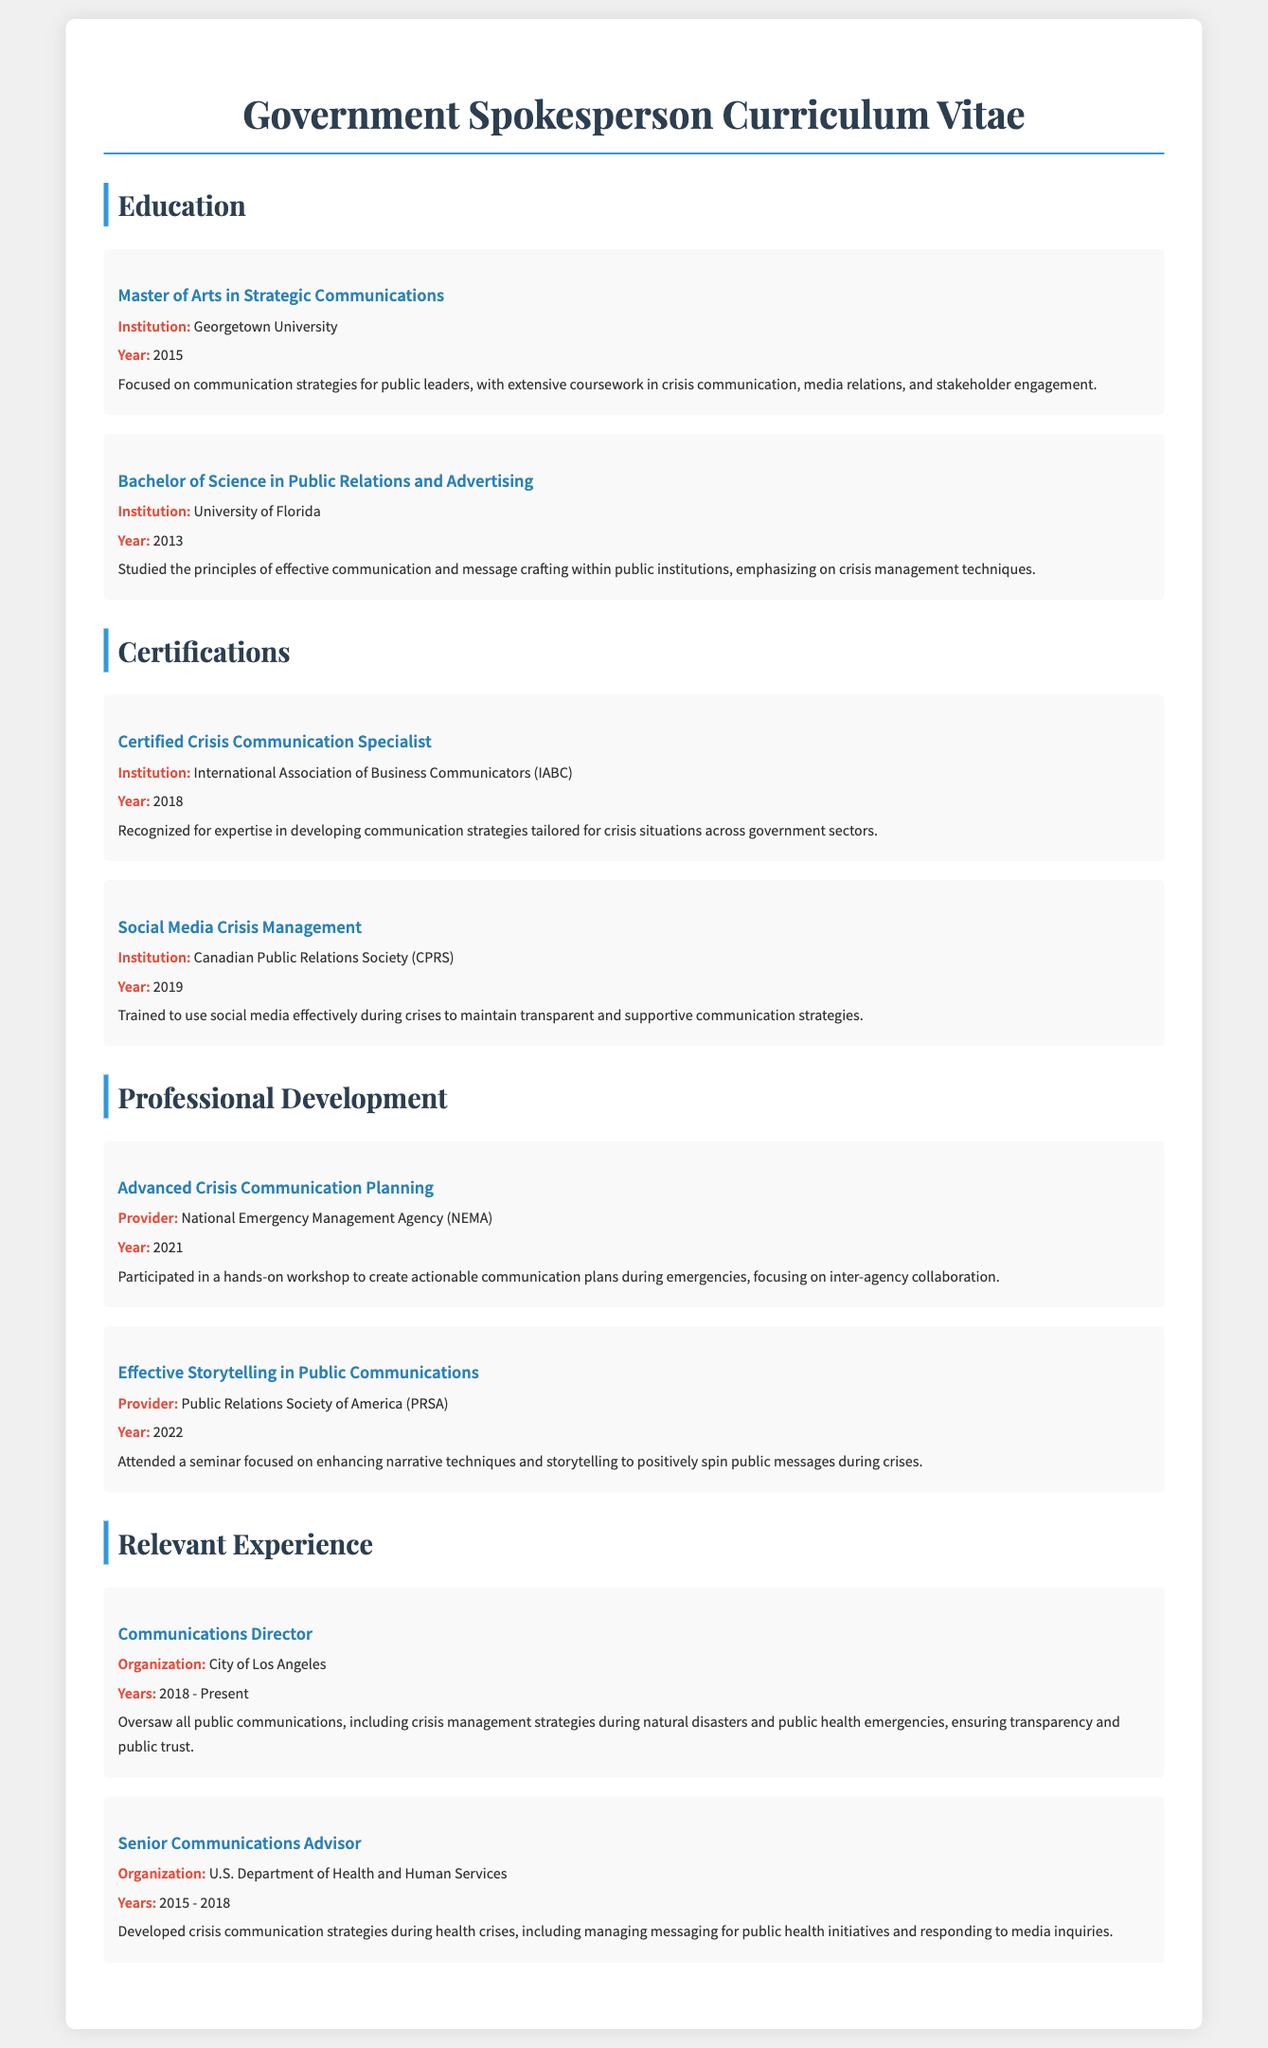what is the highest degree attained? The highest degree listed in the document is a Master's degree, which is a Master of Arts in Strategic Communications.
Answer: Master of Arts in Strategic Communications which institution awarded the Bachelor's degree? The document states that the Bachelor of Science in Public Relations and Advertising was awarded by the University of Florida.
Answer: University of Florida what year was the Certified Crisis Communication Specialist obtained? The document indicates the year of certification as 2018.
Answer: 2018 how many years did the individual work at the U.S. Department of Health and Human Services? The document mentions the individual worked there from 2015 to 2018, which is a total of 3 years.
Answer: 3 years what course focused on enhancing storytelling techniques? The document highlights a seminar titled "Effective Storytelling in Public Communications" for enhancing narrative techniques.
Answer: Effective Storytelling in Public Communications who provided the training on social media crisis management? The organization that provided this training is the Canadian Public Relations Society.
Answer: Canadian Public Relations Society what was a primary focus in the Master's program at Georgetown University? The document states that the focus was on communication strategies for public leaders, including crisis communication.
Answer: Communication strategies for public leaders in how many different sections is the CV organized? The CV is organized into four different sections: Education, Certifications, Professional Development, and Relevant Experience.
Answer: Four what role involved overseeing public communications in Los Angeles? The role mentioned is Communications Director for the City of Los Angeles.
Answer: Communications Director 